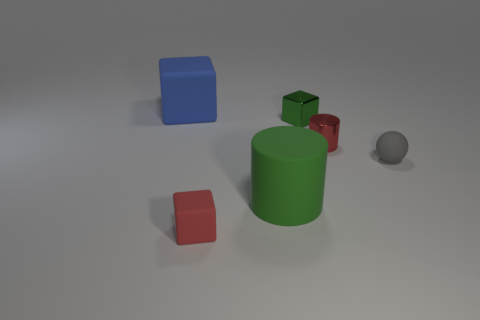Are there more red metal cylinders behind the tiny shiny block than big green matte cylinders left of the small red metal cylinder?
Provide a short and direct response. No. There is a cube that is in front of the red metallic object; is its size the same as the red metallic thing?
Offer a very short reply. Yes. How many big cylinders are right of the big matte object that is in front of the big thing behind the tiny metal cylinder?
Your answer should be compact. 0. What is the size of the object that is both behind the tiny sphere and on the right side of the tiny green metallic object?
Your answer should be compact. Small. How many other things are the same shape as the gray matte object?
Make the answer very short. 0. There is a green cylinder; how many blue cubes are in front of it?
Provide a short and direct response. 0. Is the number of green metal things to the right of the gray matte object less than the number of large rubber blocks that are to the right of the large green cylinder?
Give a very brief answer. No. There is a large object that is on the right side of the matte thing that is on the left side of the tiny rubber thing that is left of the tiny cylinder; what is its shape?
Your answer should be very brief. Cylinder. What is the shape of the object that is in front of the small sphere and right of the tiny red block?
Your answer should be compact. Cylinder. Is there another sphere that has the same material as the ball?
Your answer should be compact. No. 